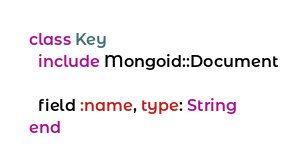<code> <loc_0><loc_0><loc_500><loc_500><_Ruby_>class Key
  include Mongoid::Document

  field :name, type: String
end
</code> 